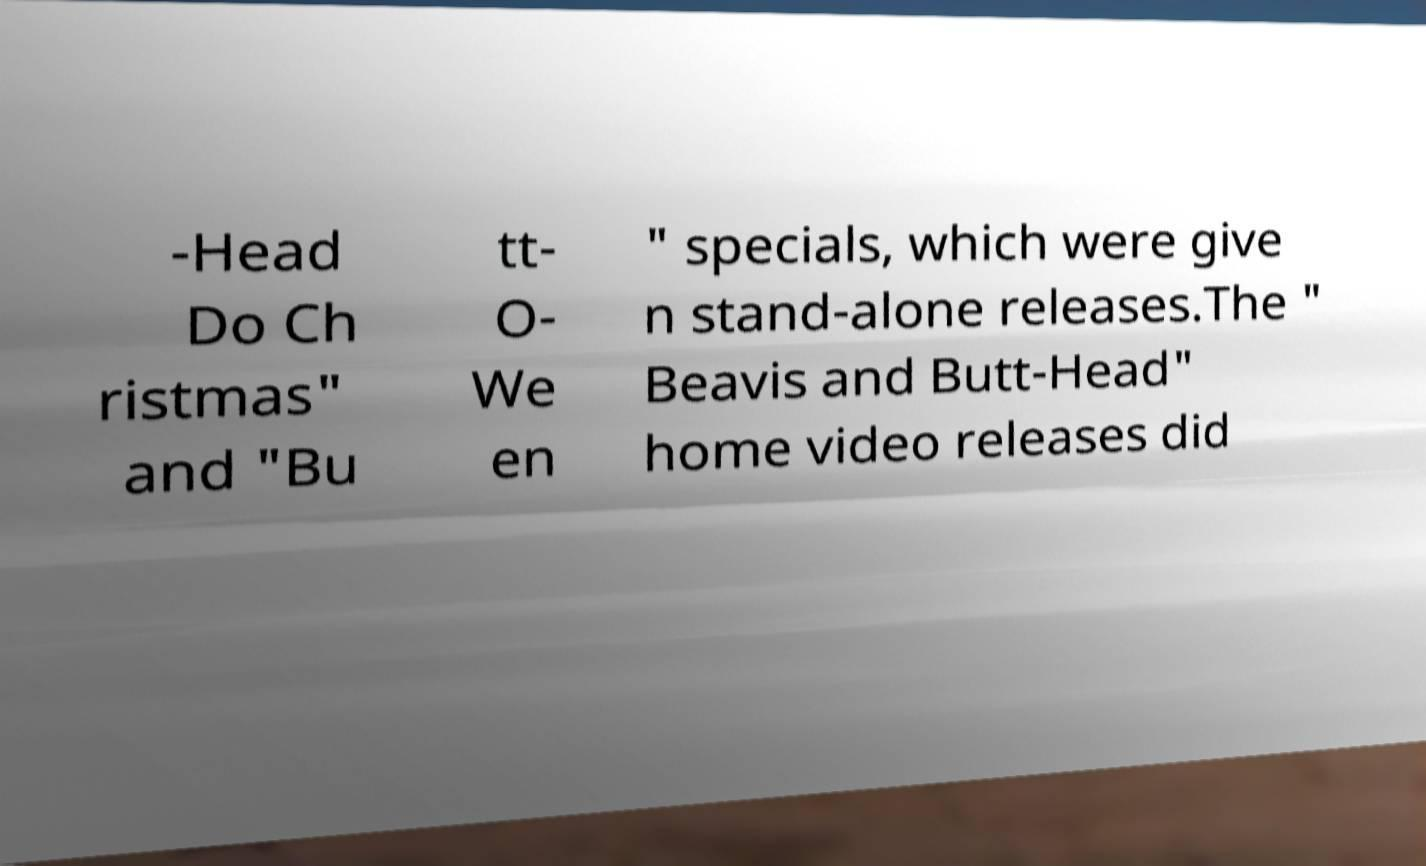Please identify and transcribe the text found in this image. -Head Do Ch ristmas" and "Bu tt- O- We en " specials, which were give n stand-alone releases.The " Beavis and Butt-Head" home video releases did 